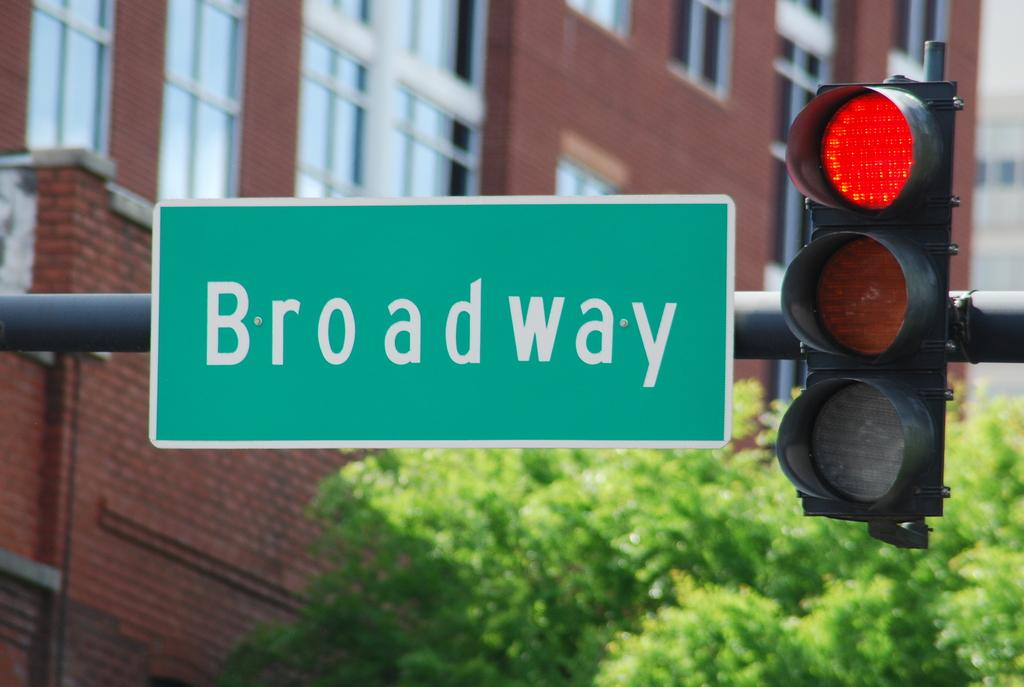<image>
Provide a brief description of the given image. The light at the Broadway intersection is red. 